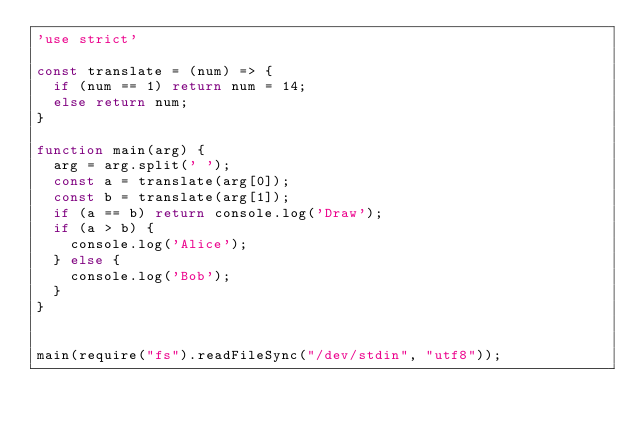<code> <loc_0><loc_0><loc_500><loc_500><_JavaScript_>'use strict'

const translate = (num) => {
  if (num == 1) return num = 14;
  else return num;
}

function main(arg) {
  arg = arg.split(' ');
  const a = translate(arg[0]);
  const b = translate(arg[1]);
  if (a == b) return console.log('Draw');
  if (a > b) {
    console.log('Alice');
  } else {
    console.log('Bob');
  }
}


main(require("fs").readFileSync("/dev/stdin", "utf8"));
</code> 